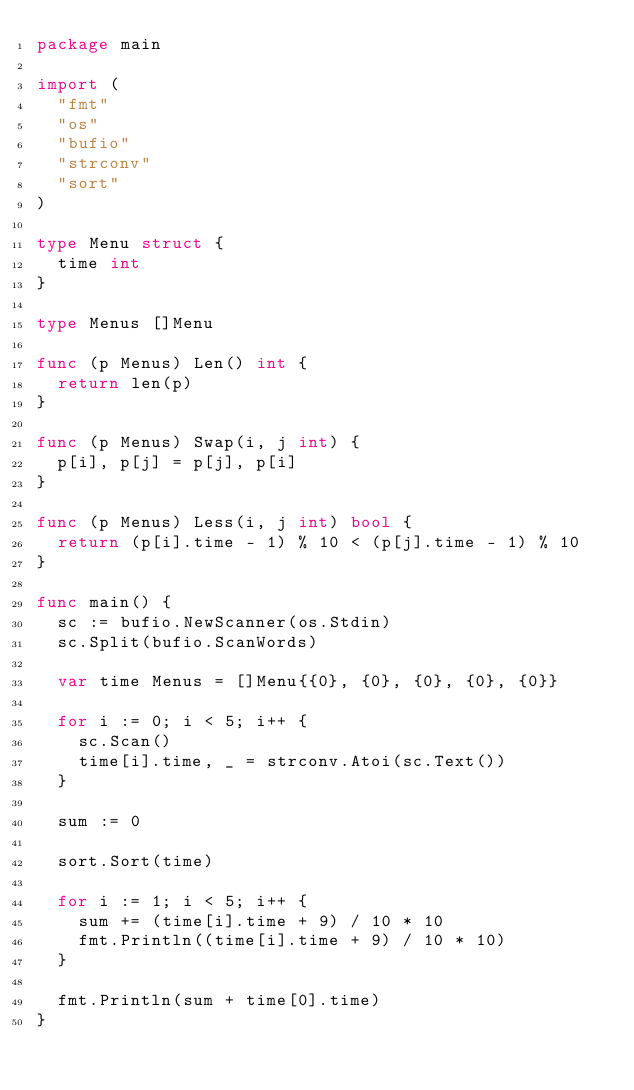Convert code to text. <code><loc_0><loc_0><loc_500><loc_500><_Go_>package main

import (
  "fmt"
  "os"
  "bufio"
  "strconv"
  "sort"
)

type Menu struct {
  time int
}

type Menus []Menu

func (p Menus) Len() int {
  return len(p)
}

func (p Menus) Swap(i, j int) {
  p[i], p[j] = p[j], p[i]
}

func (p Menus) Less(i, j int) bool {
  return (p[i].time - 1) % 10 < (p[j].time - 1) % 10
}

func main() {
  sc := bufio.NewScanner(os.Stdin)
  sc.Split(bufio.ScanWords)

  var time Menus = []Menu{{0}, {0}, {0}, {0}, {0}}

  for i := 0; i < 5; i++ {
    sc.Scan()
    time[i].time, _ = strconv.Atoi(sc.Text())
  }

  sum := 0

  sort.Sort(time)

  for i := 1; i < 5; i++ {
    sum += (time[i].time + 9) / 10 * 10
    fmt.Println((time[i].time + 9) / 10 * 10)
  }

  fmt.Println(sum + time[0].time)
}
</code> 